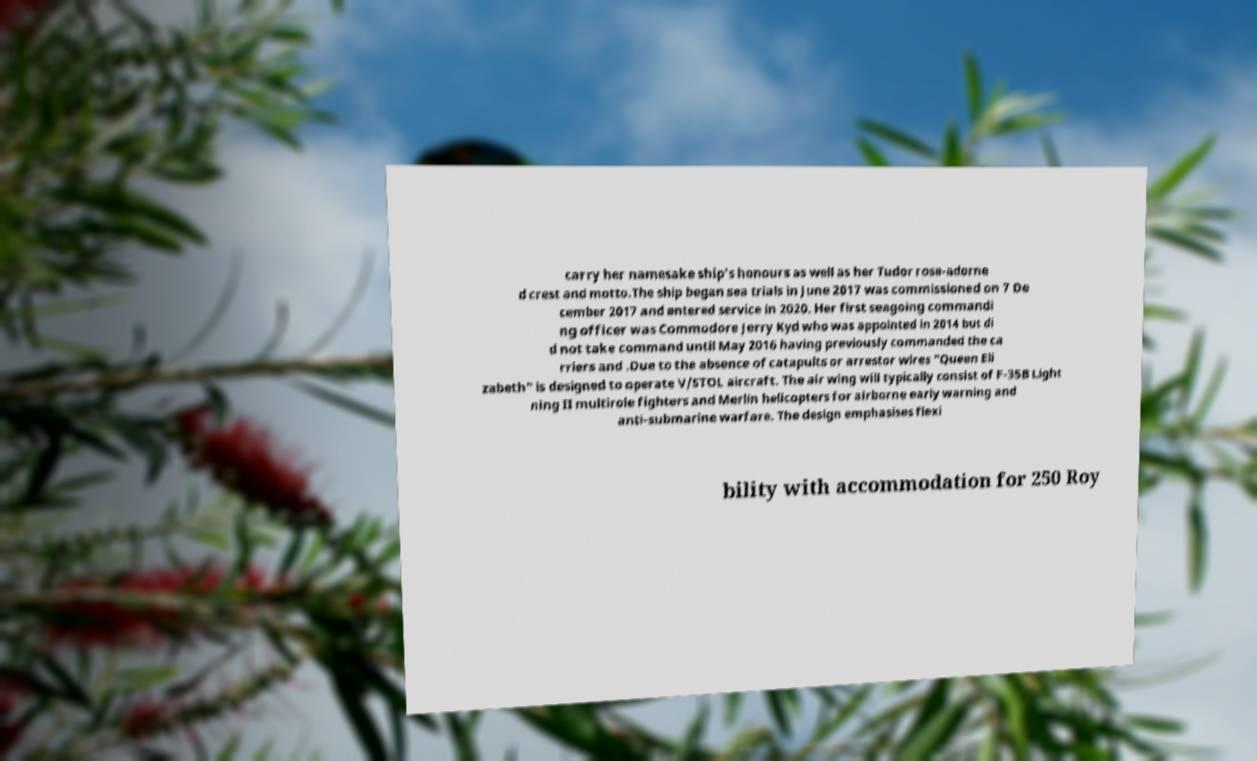Please identify and transcribe the text found in this image. carry her namesake ship's honours as well as her Tudor rose-adorne d crest and motto.The ship began sea trials in June 2017 was commissioned on 7 De cember 2017 and entered service in 2020. Her first seagoing commandi ng officer was Commodore Jerry Kyd who was appointed in 2014 but di d not take command until May 2016 having previously commanded the ca rriers and .Due to the absence of catapults or arrestor wires "Queen Eli zabeth" is designed to operate V/STOL aircraft. The air wing will typically consist of F-35B Light ning II multirole fighters and Merlin helicopters for airborne early warning and anti-submarine warfare. The design emphasises flexi bility with accommodation for 250 Roy 